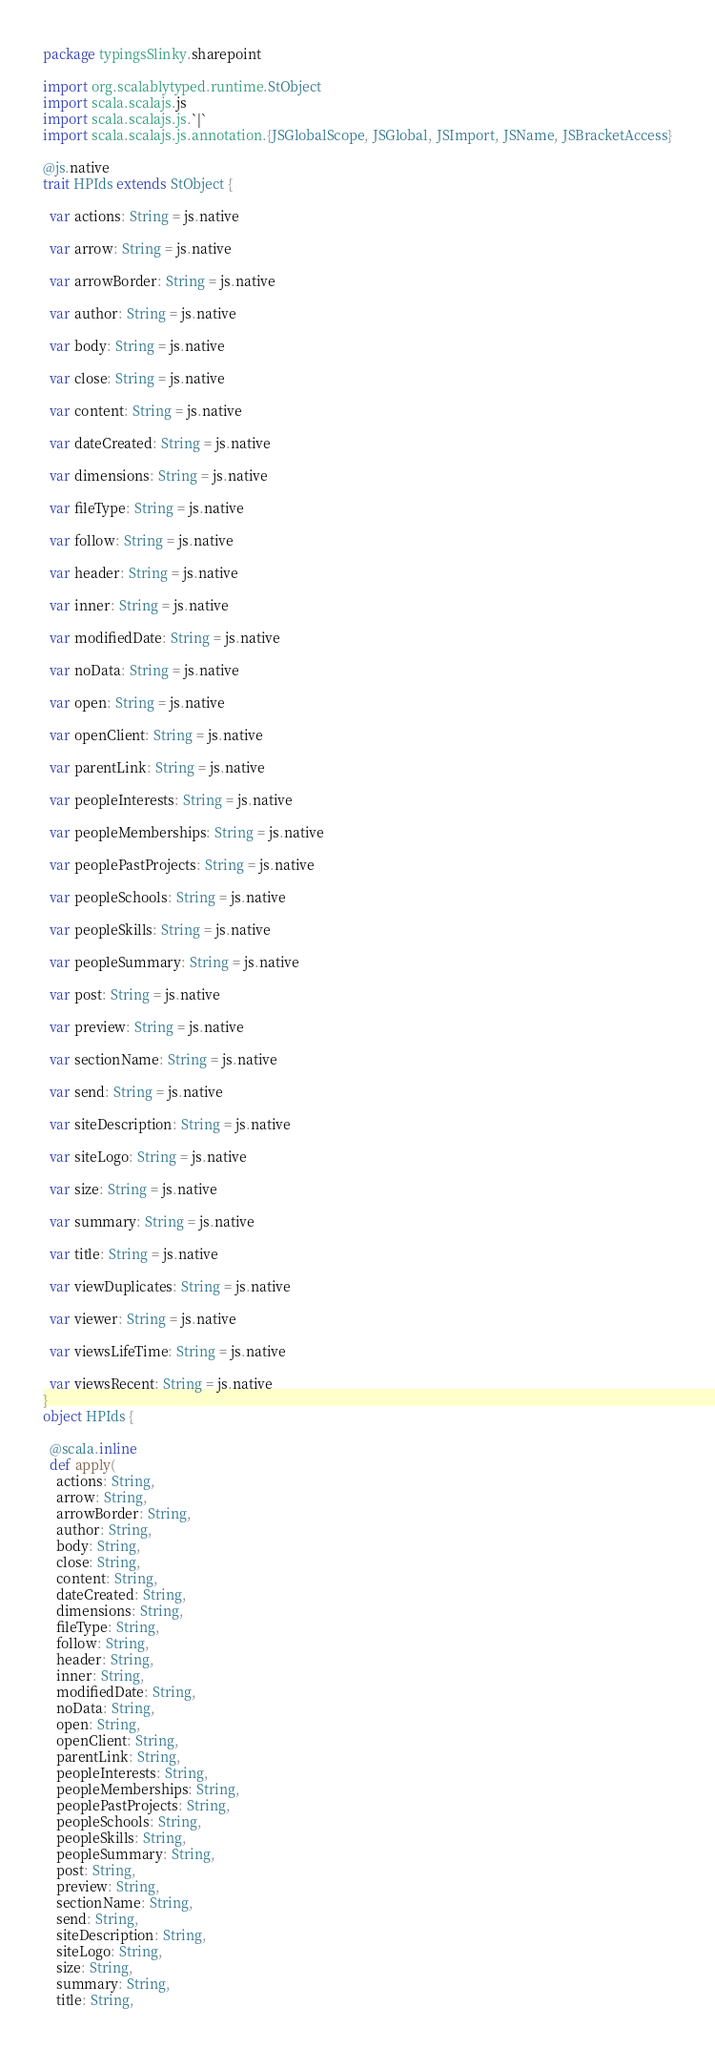Convert code to text. <code><loc_0><loc_0><loc_500><loc_500><_Scala_>package typingsSlinky.sharepoint

import org.scalablytyped.runtime.StObject
import scala.scalajs.js
import scala.scalajs.js.`|`
import scala.scalajs.js.annotation.{JSGlobalScope, JSGlobal, JSImport, JSName, JSBracketAccess}

@js.native
trait HPIds extends StObject {
  
  var actions: String = js.native
  
  var arrow: String = js.native
  
  var arrowBorder: String = js.native
  
  var author: String = js.native
  
  var body: String = js.native
  
  var close: String = js.native
  
  var content: String = js.native
  
  var dateCreated: String = js.native
  
  var dimensions: String = js.native
  
  var fileType: String = js.native
  
  var follow: String = js.native
  
  var header: String = js.native
  
  var inner: String = js.native
  
  var modifiedDate: String = js.native
  
  var noData: String = js.native
  
  var open: String = js.native
  
  var openClient: String = js.native
  
  var parentLink: String = js.native
  
  var peopleInterests: String = js.native
  
  var peopleMemberships: String = js.native
  
  var peoplePastProjects: String = js.native
  
  var peopleSchools: String = js.native
  
  var peopleSkills: String = js.native
  
  var peopleSummary: String = js.native
  
  var post: String = js.native
  
  var preview: String = js.native
  
  var sectionName: String = js.native
  
  var send: String = js.native
  
  var siteDescription: String = js.native
  
  var siteLogo: String = js.native
  
  var size: String = js.native
  
  var summary: String = js.native
  
  var title: String = js.native
  
  var viewDuplicates: String = js.native
  
  var viewer: String = js.native
  
  var viewsLifeTime: String = js.native
  
  var viewsRecent: String = js.native
}
object HPIds {
  
  @scala.inline
  def apply(
    actions: String,
    arrow: String,
    arrowBorder: String,
    author: String,
    body: String,
    close: String,
    content: String,
    dateCreated: String,
    dimensions: String,
    fileType: String,
    follow: String,
    header: String,
    inner: String,
    modifiedDate: String,
    noData: String,
    open: String,
    openClient: String,
    parentLink: String,
    peopleInterests: String,
    peopleMemberships: String,
    peoplePastProjects: String,
    peopleSchools: String,
    peopleSkills: String,
    peopleSummary: String,
    post: String,
    preview: String,
    sectionName: String,
    send: String,
    siteDescription: String,
    siteLogo: String,
    size: String,
    summary: String,
    title: String,</code> 